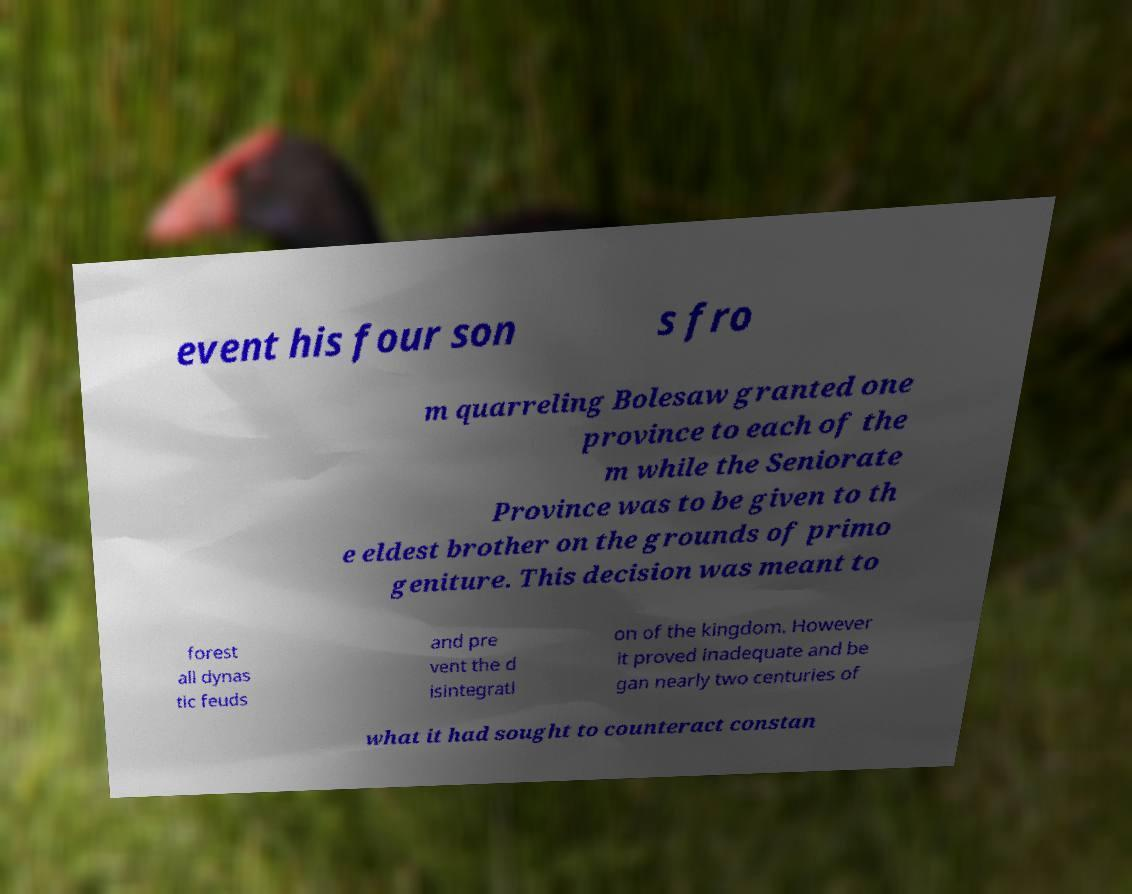Can you accurately transcribe the text from the provided image for me? event his four son s fro m quarreling Bolesaw granted one province to each of the m while the Seniorate Province was to be given to th e eldest brother on the grounds of primo geniture. This decision was meant to forest all dynas tic feuds and pre vent the d isintegrati on of the kingdom. However it proved inadequate and be gan nearly two centuries of what it had sought to counteract constan 